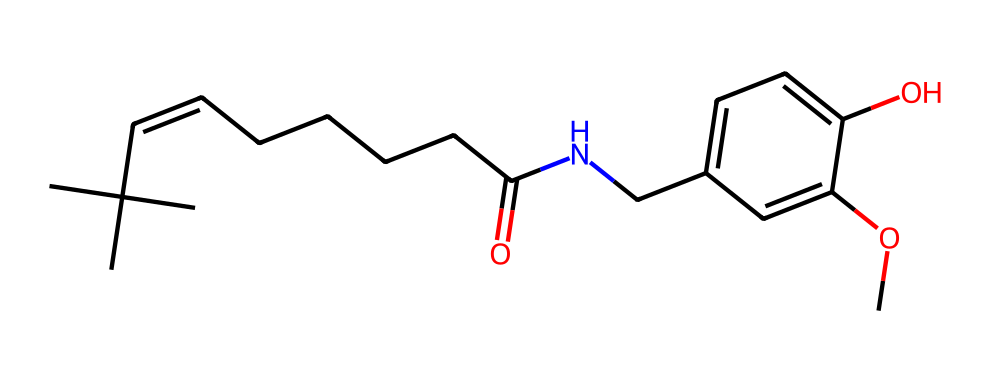What is the primary functional group present in this compound? The compound contains an ether group indicated by the -O- linkage between carbon atoms. This is evident from the methoxy (-OCH3) part in the structure.
Answer: ether How many carbon atoms are present in capsaicin? By analyzing the structure, counting reveals a total of 18 carbon atoms throughout the entire compound.
Answer: 18 What type of bond is primarily found between the carbon and nitrogen in this compound? The bond connecting carbon to nitrogen in this compound is a single covalent bond (C-N), observed in the structure of the amide portion.
Answer: single What is the longest carbon chain in capsaicin? The longest continuous carbon chain is from the amide group through to the branched aliphatic tail, which contains 10 carbon atoms.
Answer: 10 Does capsaicin contain any cyclic structures? A quick inspection of the structure reveals no closed loops or rings, confirming it is a non-cyclic compound.
Answer: no How many hydroxyl (-OH) groups are present in capsaicin? The structure shows two distinct hydroxyl groups attached to the aromatic ring as indicated by their positions, leading to a total of two -OH functionalities.
Answer: 2 What is the role of the nitrogen atom in the structure of capsaicin? The nitrogen atom is part of the amide functional group, contributing to the compound's bioactivity and interaction with receptor proteins in the body.
Answer: amide 